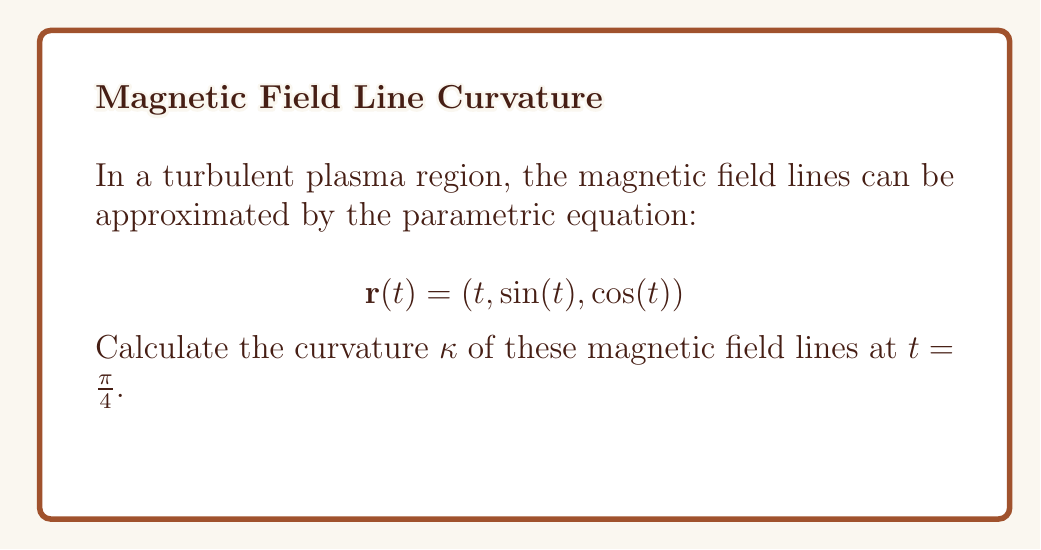Could you help me with this problem? To calculate the curvature of a parametric curve, we use the formula:

$$\kappa = \frac{|\mathbf{r}'(t) \times \mathbf{r}''(t)|}{|\mathbf{r}'(t)|^3}$$

Step 1: Calculate $\mathbf{r}'(t)$
$$\mathbf{r}'(t) = (1, \cos(t), -\sin(t))$$

Step 2: Calculate $\mathbf{r}''(t)$
$$\mathbf{r}''(t) = (0, -\sin(t), -\cos(t))$$

Step 3: Calculate $\mathbf{r}'(t) \times \mathbf{r}''(t)$
$$\mathbf{r}'(t) \times \mathbf{r}''(t) = \begin{vmatrix} 
\mathbf{i} & \mathbf{j} & \mathbf{k} \\
1 & \cos(t) & -\sin(t) \\
0 & -\sin(t) & -\cos(t)
\end{vmatrix}$$

$$= (-\cos^2(t) - \sin^2(t))\mathbf{i} + \sin(t)\mathbf{j} + \cos(t)\mathbf{k}$$

$$= -\mathbf{i} + \sin(t)\mathbf{j} + \cos(t)\mathbf{k}$$

Step 4: Calculate $|\mathbf{r}'(t) \times \mathbf{r}''(t)|$
$$|\mathbf{r}'(t) \times \mathbf{r}''(t)| = \sqrt{1^2 + \sin^2(t) + \cos^2(t)} = \sqrt{2}$$

Step 5: Calculate $|\mathbf{r}'(t)|$
$$|\mathbf{r}'(t)| = \sqrt{1^2 + \cos^2(t) + \sin^2(t)} = \sqrt{2}$$

Step 6: Calculate $\kappa$ at $t = \frac{\pi}{4}$
$$\kappa = \frac{|\mathbf{r}'(t) \times \mathbf{r}''(t)|}{|\mathbf{r}'(t)|^3} = \frac{\sqrt{2}}{(\sqrt{2})^3} = \frac{\sqrt{2}}{2\sqrt{2}} = \frac{1}{2}$$
Answer: $\kappa = \frac{1}{2}$ 